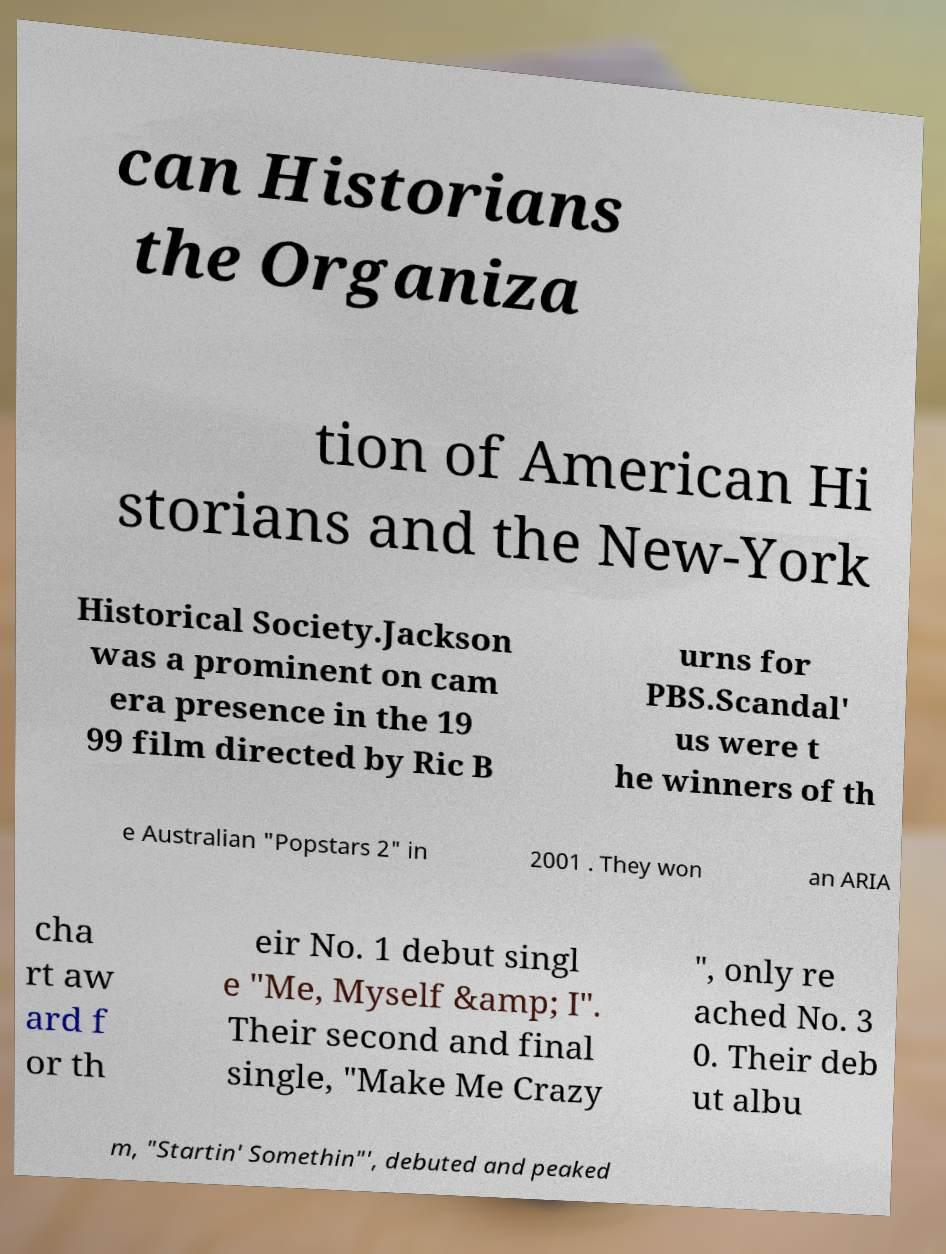For documentation purposes, I need the text within this image transcribed. Could you provide that? can Historians the Organiza tion of American Hi storians and the New-York Historical Society.Jackson was a prominent on cam era presence in the 19 99 film directed by Ric B urns for PBS.Scandal' us were t he winners of th e Australian "Popstars 2" in 2001 . They won an ARIA cha rt aw ard f or th eir No. 1 debut singl e "Me, Myself &amp; I". Their second and final single, "Make Me Crazy ", only re ached No. 3 0. Their deb ut albu m, "Startin' Somethin"', debuted and peaked 